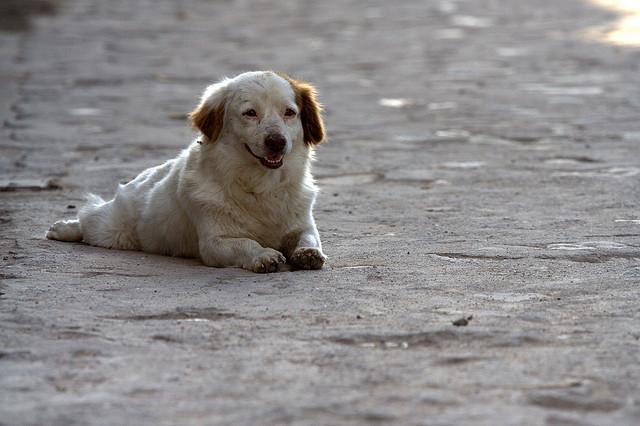Has the dog been groomed?
Short answer required. No. Is the dog running?
Be succinct. No. What color are the dog's ears?
Give a very brief answer. Brown. What color is the dirt on the ground?
Keep it brief. Brown. Is the dog wearing a collar?
Give a very brief answer. No. What color is the asphalt?
Write a very short answer. Gray. 